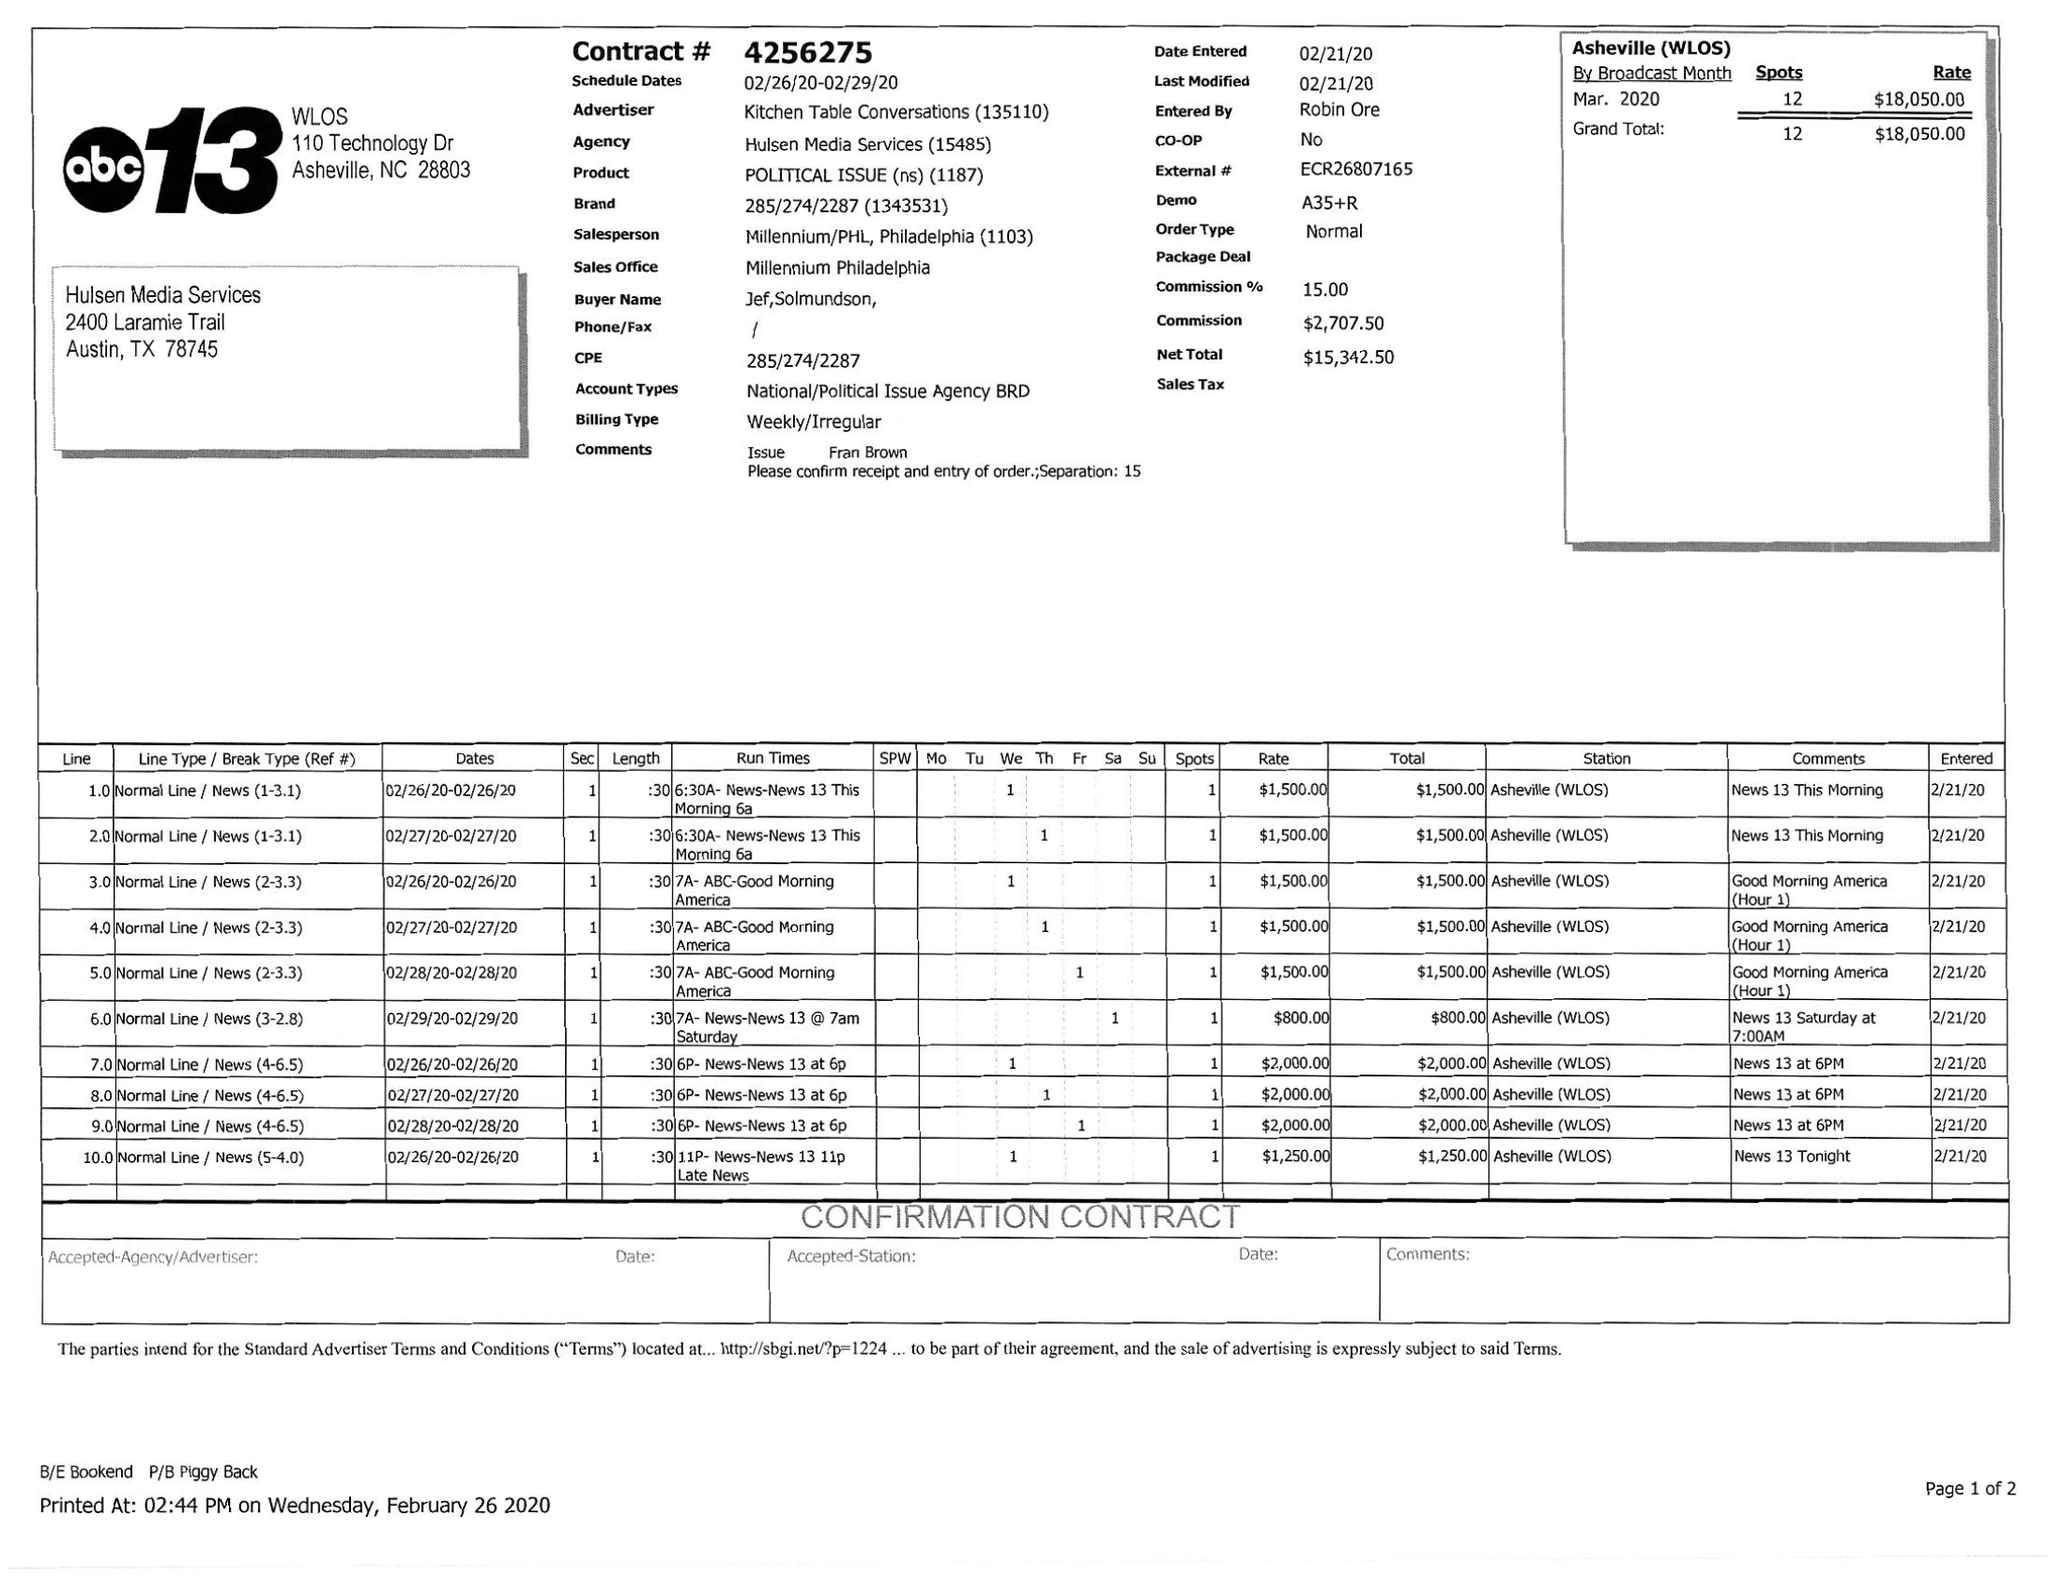What is the value for the advertiser?
Answer the question using a single word or phrase. KITCHEN TABLE CONVERSATIONS 